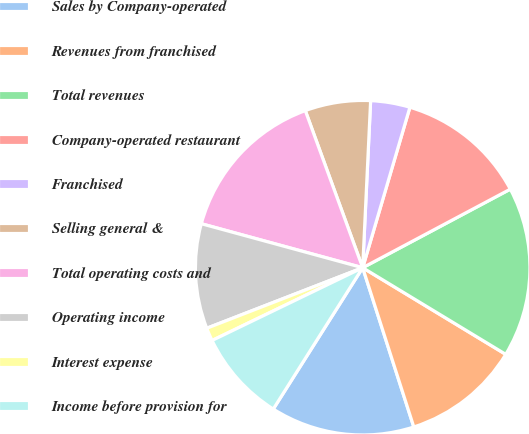Convert chart to OTSL. <chart><loc_0><loc_0><loc_500><loc_500><pie_chart><fcel>Sales by Company-operated<fcel>Revenues from franchised<fcel>Total revenues<fcel>Company-operated restaurant<fcel>Franchised<fcel>Selling general &<fcel>Total operating costs and<fcel>Operating income<fcel>Interest expense<fcel>Income before provision for<nl><fcel>13.92%<fcel>11.39%<fcel>16.45%<fcel>12.66%<fcel>3.8%<fcel>6.33%<fcel>15.19%<fcel>10.13%<fcel>1.27%<fcel>8.86%<nl></chart> 